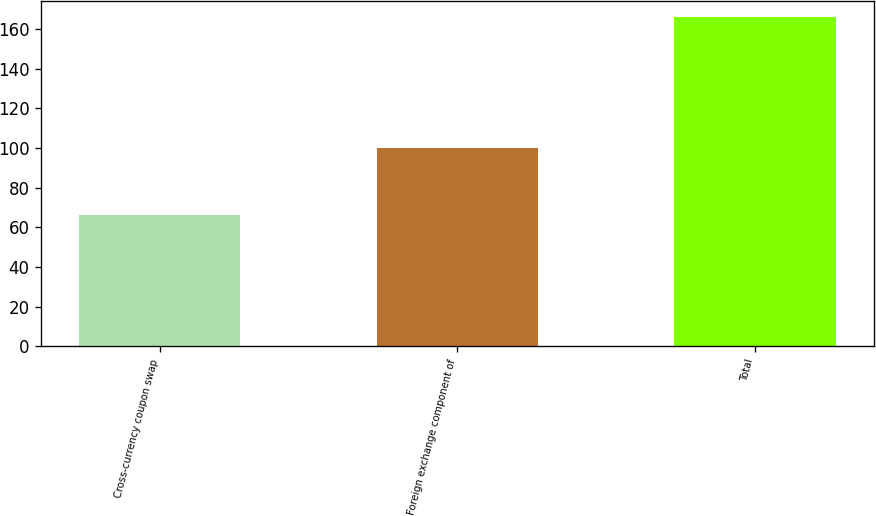<chart> <loc_0><loc_0><loc_500><loc_500><bar_chart><fcel>Cross-currency coupon swap<fcel>Foreign exchange component of<fcel>Total<nl><fcel>66<fcel>100<fcel>166<nl></chart> 